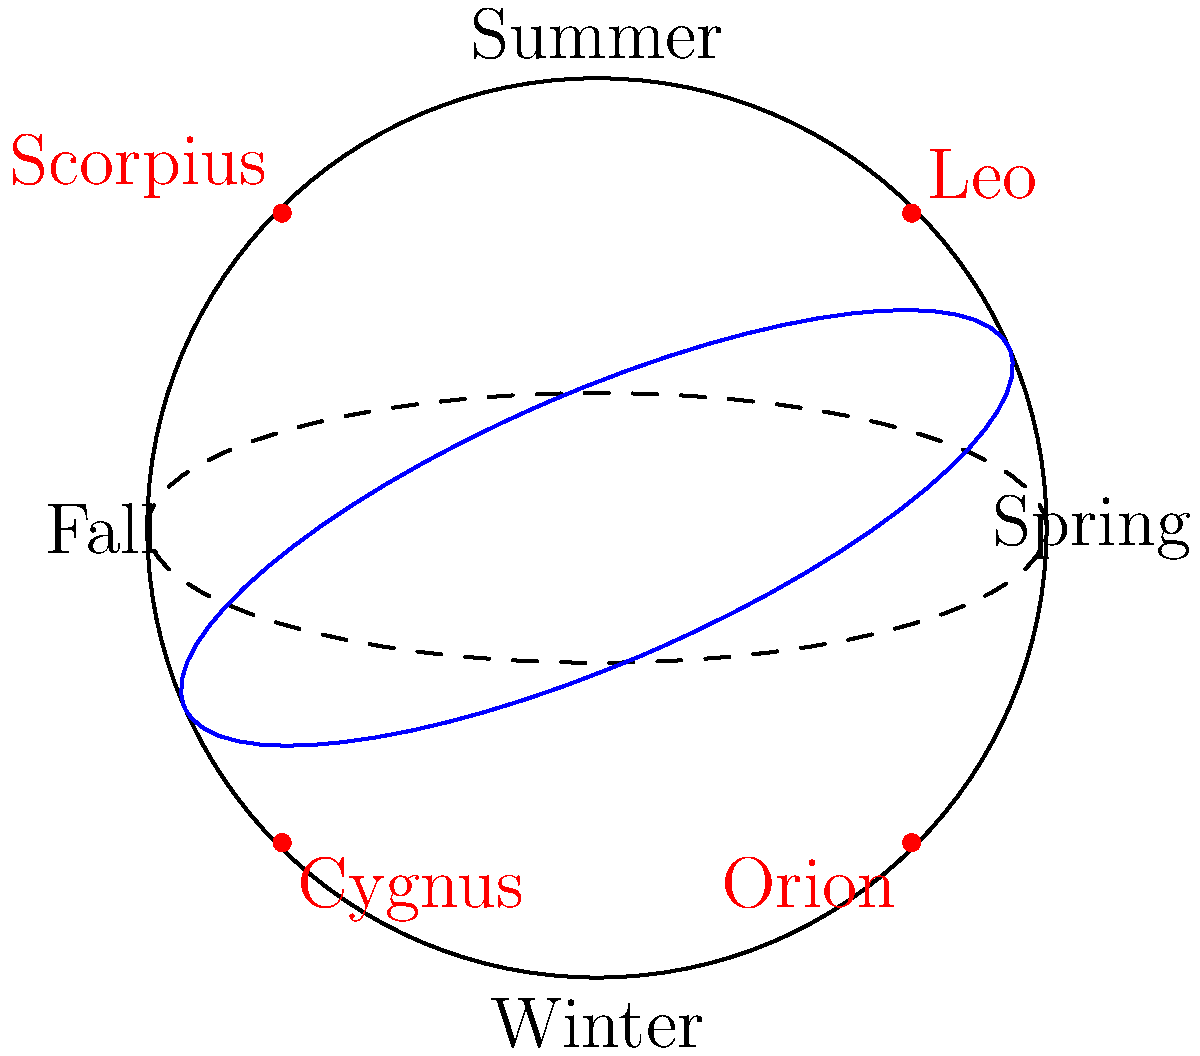As you enjoy stargazing with friends throughout the year, you notice different constellations becoming visible in different seasons. Which constellation is most prominently visible in the winter night sky in the Northern Hemisphere? To understand why certain constellations are visible during specific seasons, we need to consider the Earth's position relative to the Sun throughout the year:

1. The Earth orbits the Sun in an elliptical path, completing one revolution in a year.

2. The Earth's axis is tilted at an angle of approximately 23.5 degrees relative to its orbital plane.

3. This tilt causes the seasons and affects which constellations are visible at night during different times of the year.

4. In winter (for the Northern Hemisphere), the Earth is positioned such that the night side faces away from the Sun and towards the part of the sky containing winter constellations.

5. One of the most recognizable and prominent winter constellations is Orion, the Hunter.

6. Orion is visible in the night sky from late autumn to early spring, but it reaches its highest point in the sky during winter nights.

7. Other winter constellations include Taurus, Gemini, and Canis Major, but Orion is generally considered the most easily recognizable and prominent.

8. In contrast, summer constellations like Scorpius and Cygnus are not visible during winter nights in the Northern Hemisphere, as they are behind the Sun from our perspective.

Therefore, based on its prominence and ease of recognition during winter nights, Orion is the constellation most associated with the winter sky in the Northern Hemisphere.
Answer: Orion 